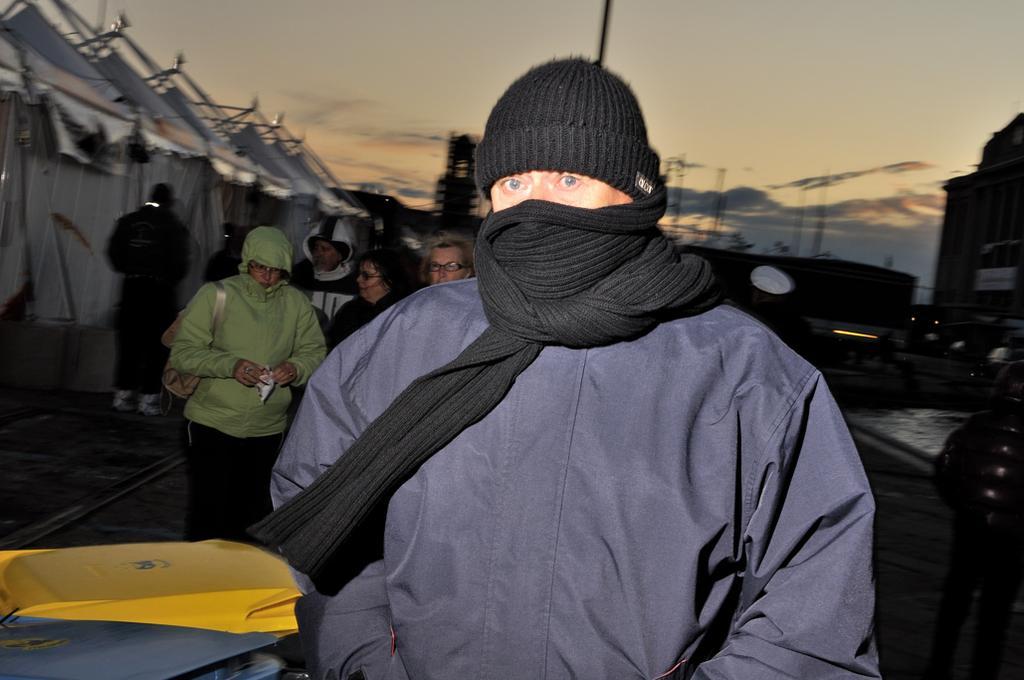Describe this image in one or two sentences. In this picture we can see some people are standing, a person in the front is wearing a cap and a mask, on the left side there are tents, on the right side we can see a building, there is the sky at the top of the picture. 